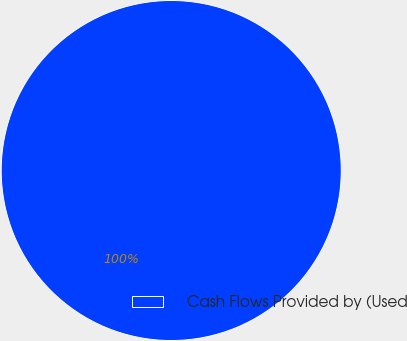Convert chart. <chart><loc_0><loc_0><loc_500><loc_500><pie_chart><fcel>Cash Flows Provided by (Used<nl><fcel>100.0%<nl></chart> 